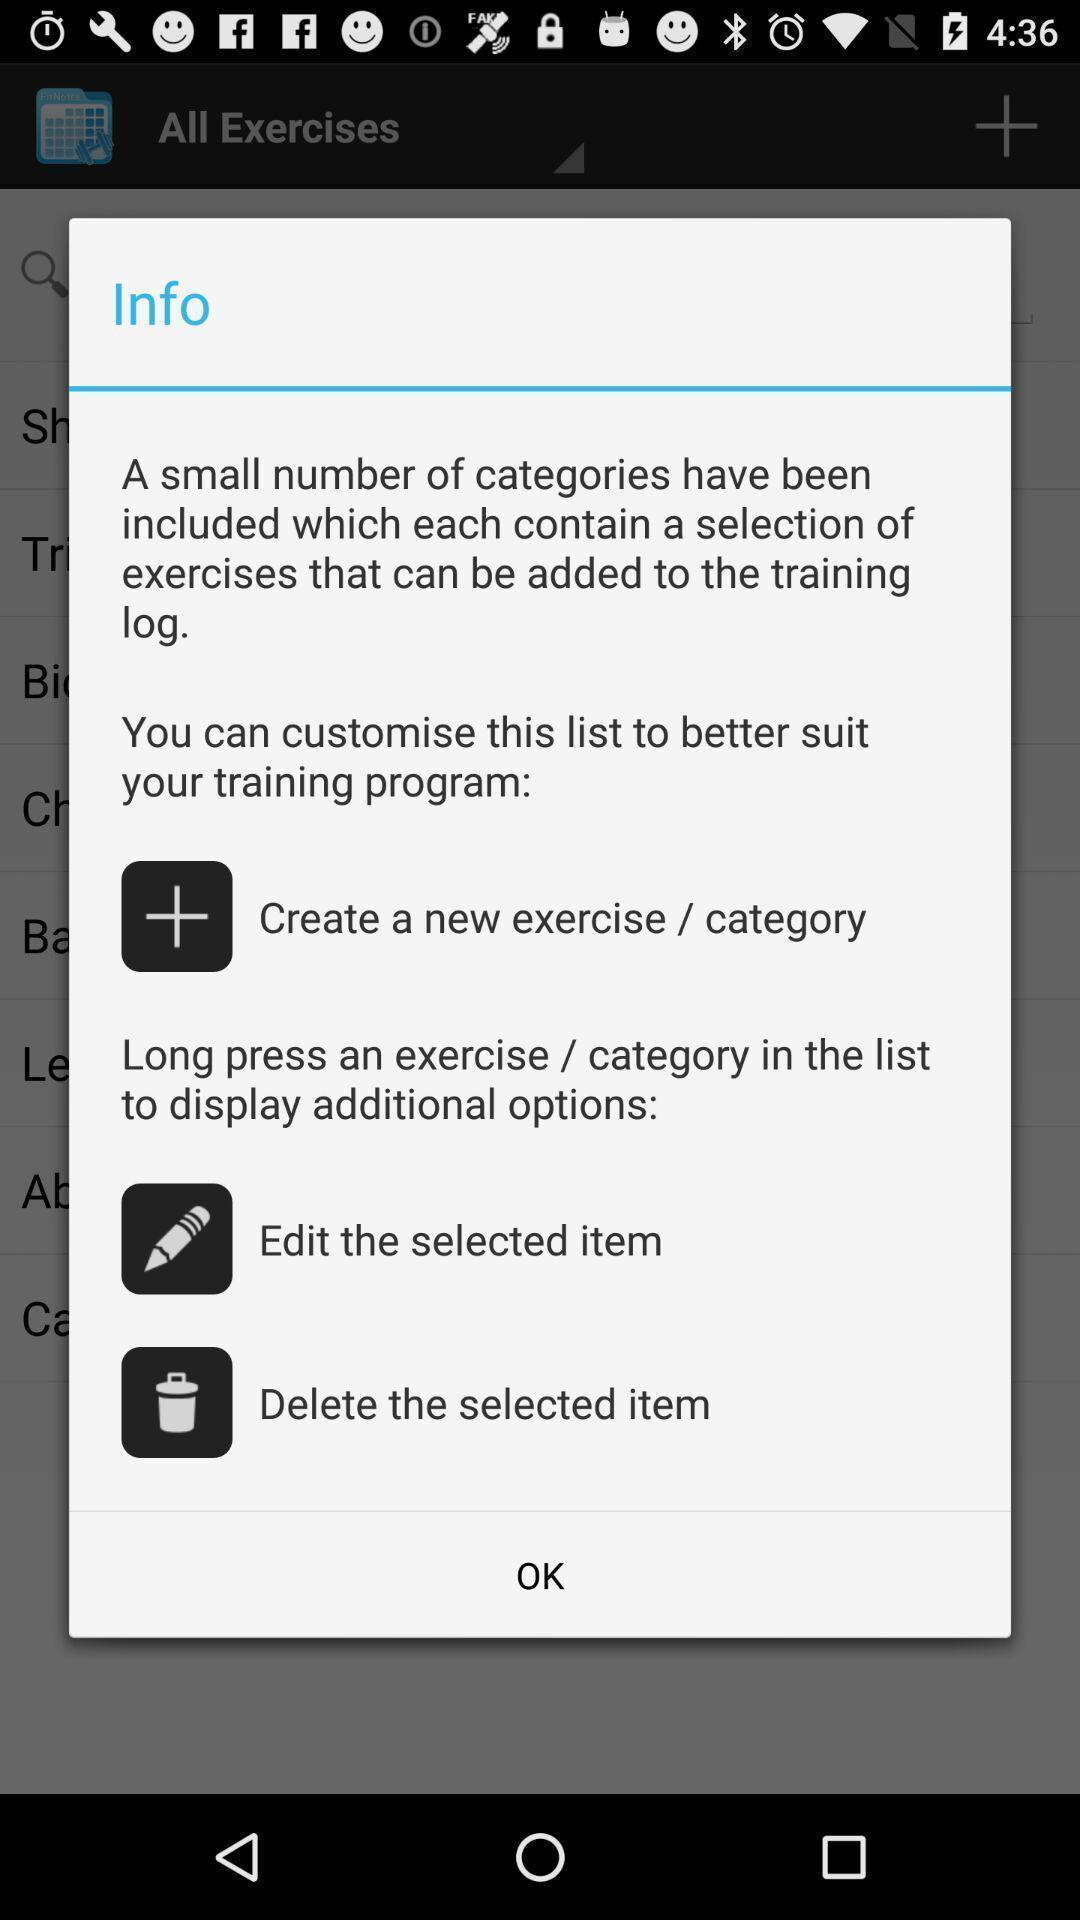Please provide a description for this image. Popup up showing info with few options in health app. 